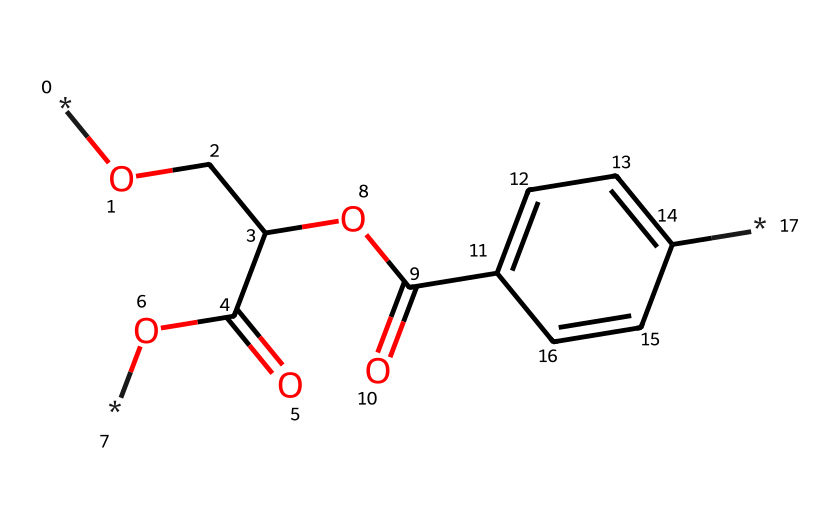What is the main functional group present in this chemical structure? Looking at the SMILES representation and the structure, the key functional groups indicated are the carboxylic acid (-COOH) and ester (–COO–) groups. The presence of -C(=O)O indicates the carboxylic acid group, confirming its presence.
Answer: carboxylic acid How many carbon atoms are in the structure? By inspecting the SMILES notation, the carbon atoms can be counted. The -C(=O)O immediately suggests that there are several carbon atoms linked in chains or rings. Counting them gives a total of 10 carbon atoms.
Answer: 10 What type of polymer does this chemical structure represent? Given the repeating units suggested by the ester and aromatic components of the structure, this is indicative of a polyester, specifically polyethylene terephthalate (PET).
Answer: polyester What is the structural notation for the aromatic ring present in this chemical? In the SMILES representation, the 'c1ccc(cc1)' denotes a benzene-like structure, indicating an aromatic ring is present here, which is common in polymers for added strength and properties.
Answer: aromatic ring How many oxygen atoms are found in the structure? By looking closely at the SMILES and counting each 'O' in the chemical structure, we can find there are 4 oxygen atoms present structurally at various points.
Answer: 4 What property does the ester functional group impart to this polymer? The presence of the ester functional group provides flexibility to the polymer chain while also contributing to its overall durability, making it suitable for applications like plastic water bottles.
Answer: flexibility 